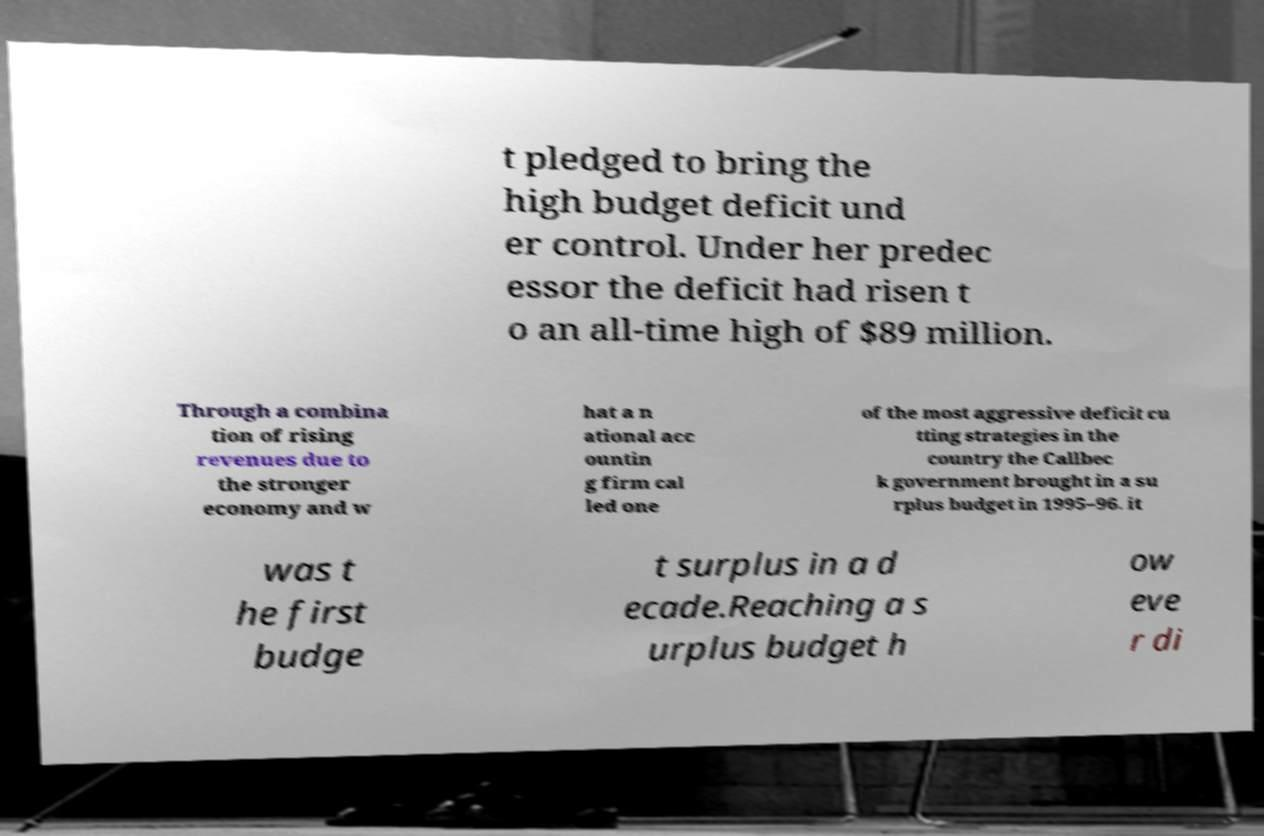There's text embedded in this image that I need extracted. Can you transcribe it verbatim? t pledged to bring the high budget deficit und er control. Under her predec essor the deficit had risen t o an all-time high of $89 million. Through a combina tion of rising revenues due to the stronger economy and w hat a n ational acc ountin g firm cal led one of the most aggressive deficit cu tting strategies in the country the Callbec k government brought in a su rplus budget in 1995–96. it was t he first budge t surplus in a d ecade.Reaching a s urplus budget h ow eve r di 